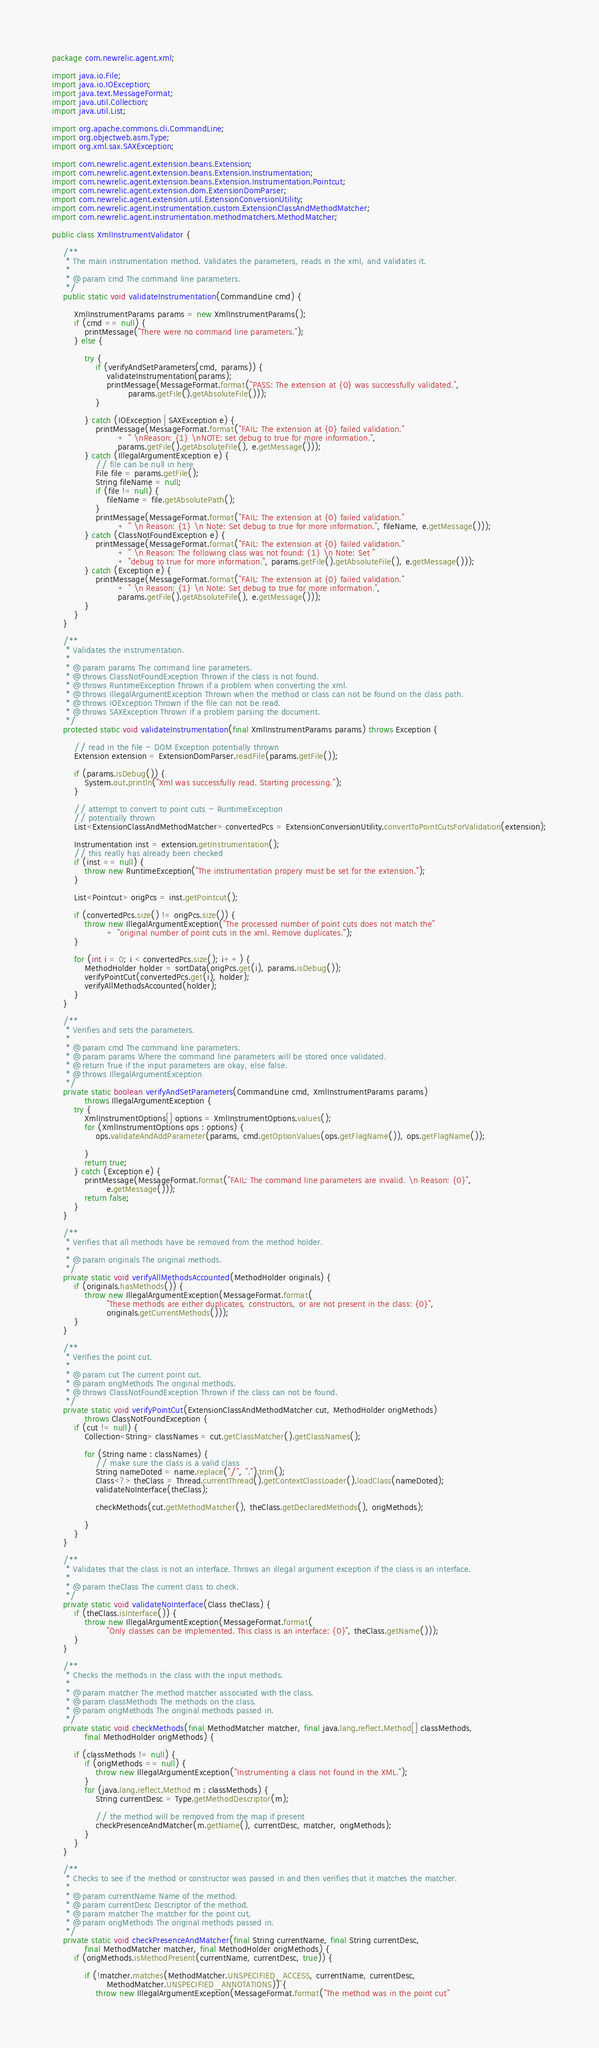Convert code to text. <code><loc_0><loc_0><loc_500><loc_500><_Java_>package com.newrelic.agent.xml;

import java.io.File;
import java.io.IOException;
import java.text.MessageFormat;
import java.util.Collection;
import java.util.List;

import org.apache.commons.cli.CommandLine;
import org.objectweb.asm.Type;
import org.xml.sax.SAXException;

import com.newrelic.agent.extension.beans.Extension;
import com.newrelic.agent.extension.beans.Extension.Instrumentation;
import com.newrelic.agent.extension.beans.Extension.Instrumentation.Pointcut;
import com.newrelic.agent.extension.dom.ExtensionDomParser;
import com.newrelic.agent.extension.util.ExtensionConversionUtility;
import com.newrelic.agent.instrumentation.custom.ExtensionClassAndMethodMatcher;
import com.newrelic.agent.instrumentation.methodmatchers.MethodMatcher;

public class XmlInstrumentValidator {

    /**
     * The main instrumentation method. Validates the parameters, reads in the xml, and validates it.
     * 
     * @param cmd The command line parameters.
     */
    public static void validateInstrumentation(CommandLine cmd) {

        XmlInstrumentParams params = new XmlInstrumentParams();
        if (cmd == null) {
            printMessage("There were no command line parameters.");
        } else {

            try {
                if (verifyAndSetParameters(cmd, params)) {
                    validateInstrumentation(params);
                    printMessage(MessageFormat.format("PASS: The extension at {0} was successfully validated.",
                            params.getFile().getAbsoluteFile()));
                }

            } catch (IOException | SAXException e) {
                printMessage(MessageFormat.format("FAIL: The extension at {0} failed validation."
                        + " \nReason: {1} \nNOTE: set debug to true for more information.",
                        params.getFile().getAbsoluteFile(), e.getMessage()));
            } catch (IllegalArgumentException e) {
                // file can be null in here
                File file = params.getFile();
                String fileName = null;
                if (file != null) {
                    fileName = file.getAbsolutePath();
                }
                printMessage(MessageFormat.format("FAIL: The extension at {0} failed validation."
                        + " \n Reason: {1} \n Note: Set debug to true for more information.", fileName, e.getMessage()));
            } catch (ClassNotFoundException e) {
                printMessage(MessageFormat.format("FAIL: The extension at {0} failed validation."
                        + " \n Reason: The following class was not found: {1} \n Note: Set "
                        + "debug to true for more information.", params.getFile().getAbsoluteFile(), e.getMessage()));
            } catch (Exception e) {
                printMessage(MessageFormat.format("FAIL: The extension at {0} failed validation."
                        + " \n Reason: {1} \n Note: Set debug to true for more information.",
                        params.getFile().getAbsoluteFile(), e.getMessage()));
            }
        }
    }

    /**
     * Validates the instrumentation.
     * 
     * @param params The command line parameters.
     * @throws ClassNotFoundException Thrown if the class is not found.
     * @throws RuntimeException Thrown if a problem when converting the xml.
     * @throws IllegalArgumentException Thrown when the method or class can not be found on the class path.
     * @throws IOException Thrown if the file can not be read.
     * @throws SAXException Thrown if a problem parsing the document.
     */
    protected static void validateInstrumentation(final XmlInstrumentParams params) throws Exception {

        // read in the file - DOM Exception potentially thrown
        Extension extension = ExtensionDomParser.readFile(params.getFile());

        if (params.isDebug()) {
            System.out.println("Xml was successfully read. Starting processing.");
        }

        // attempt to convert to point cuts - RuntimeException
        // potentially thrown
        List<ExtensionClassAndMethodMatcher> convertedPcs = ExtensionConversionUtility.convertToPointCutsForValidation(extension);

        Instrumentation inst = extension.getInstrumentation();
        // this really has already been checked
        if (inst == null) {
            throw new RuntimeException("The instrumentation propery must be set for the extension.");
        }

        List<Pointcut> origPcs = inst.getPointcut();

        if (convertedPcs.size() != origPcs.size()) {
            throw new IllegalArgumentException("The processed number of point cuts does not match the"
                    + "original number of point cuts in the xml. Remove duplicates.");
        }

        for (int i = 0; i < convertedPcs.size(); i++) {
            MethodHolder holder = sortData(origPcs.get(i), params.isDebug());
            verifyPointCut(convertedPcs.get(i), holder);
            verifyAllMethodsAccounted(holder);
        }
    }

    /**
     * Verifies and sets the parameters.
     * 
     * @param cmd The command line parameters.
     * @param params Where the command line parameters will be stored once validated.
     * @return True if the input parameters are okay, else false.
     * @throws IllegalArgumentException
     */
    private static boolean verifyAndSetParameters(CommandLine cmd, XmlInstrumentParams params)
            throws IllegalArgumentException {
        try {
            XmlInstrumentOptions[] options = XmlInstrumentOptions.values();
            for (XmlInstrumentOptions ops : options) {
                ops.validateAndAddParameter(params, cmd.getOptionValues(ops.getFlagName()), ops.getFlagName());

            }
            return true;
        } catch (Exception e) {
            printMessage(MessageFormat.format("FAIL: The command line parameters are invalid. \n Reason: {0}",
                    e.getMessage()));
            return false;
        }
    }

    /**
     * Verifies that all methods have be removed from the method holder.
     * 
     * @param originals The original methods.
     */
    private static void verifyAllMethodsAccounted(MethodHolder originals) {
        if (originals.hasMethods()) {
            throw new IllegalArgumentException(MessageFormat.format(
                    "These methods are either duplicates, constructors, or are not present in the class: {0}",
                    originals.getCurrentMethods()));
        }
    }

    /**
     * Verifies the point cut.
     * 
     * @param cut The current point cut.
     * @param origMethods The original methods.
     * @throws ClassNotFoundException Thrown if the class can not be found.
     */
    private static void verifyPointCut(ExtensionClassAndMethodMatcher cut, MethodHolder origMethods)
            throws ClassNotFoundException {
        if (cut != null) {
            Collection<String> classNames = cut.getClassMatcher().getClassNames();

            for (String name : classNames) {
                // make sure the class is a valid class
                String nameDoted = name.replace("/", ".").trim();
                Class<?> theClass = Thread.currentThread().getContextClassLoader().loadClass(nameDoted);
                validateNoInterface(theClass);

                checkMethods(cut.getMethodMatcher(), theClass.getDeclaredMethods(), origMethods);

            }
        }
    }

    /**
     * Validates that the class is not an interface. Throws an illegal argument exception if the class is an interface.
     * 
     * @param theClass The current class to check.
     */
    private static void validateNoInterface(Class theClass) {
        if (theClass.isInterface()) {
            throw new IllegalArgumentException(MessageFormat.format(
                    "Only classes can be implemented. This class is an interface: {0}", theClass.getName()));
        }
    }

    /**
     * Checks the methods in the class with the input methods.
     * 
     * @param matcher The method matcher associated with the class.
     * @param classMethods The methods on the class.
     * @param origMethods The original methods passed in.
     */
    private static void checkMethods(final MethodMatcher matcher, final java.lang.reflect.Method[] classMethods,
            final MethodHolder origMethods) {

        if (classMethods != null) {
            if (origMethods == null) {
                throw new IllegalArgumentException("Instrumenting a class not found in the XML.");
            }
            for (java.lang.reflect.Method m : classMethods) {
                String currentDesc = Type.getMethodDescriptor(m);

                // the method will be removed from the map if present
                checkPresenceAndMatcher(m.getName(), currentDesc, matcher, origMethods);
            }
        }
    }

    /**
     * Checks to see if the method or constructor was passed in and then verifies that it matches the matcher.
     * 
     * @param currentName Name of the method.
     * @param currentDesc Descriptor of the method.
     * @param matcher The matcher for the point cut,
     * @param origMethods The original methods passed in.
     */
    private static void checkPresenceAndMatcher(final String currentName, final String currentDesc,
            final MethodMatcher matcher, final MethodHolder origMethods) {
        if (origMethods.isMethodPresent(currentName, currentDesc, true)) {

            if (!matcher.matches(MethodMatcher.UNSPECIFIED_ACCESS, currentName, currentDesc,
                    MethodMatcher.UNSPECIFIED_ANNOTATIONS)) {
                throw new IllegalArgumentException(MessageFormat.format("The method was in the point cut"</code> 